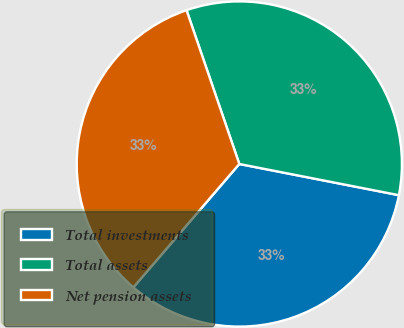Convert chart. <chart><loc_0><loc_0><loc_500><loc_500><pie_chart><fcel>Total investments<fcel>Total assets<fcel>Net pension assets<nl><fcel>33.22%<fcel>33.33%<fcel>33.44%<nl></chart> 